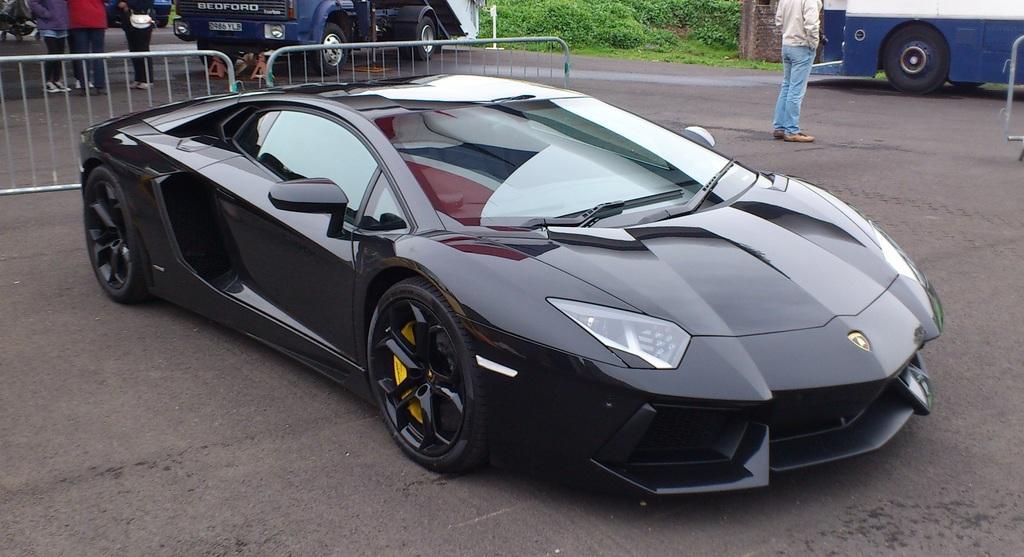Could you give a brief overview of what you see in this image? In this picture I can see vehicles on the road, there are barriers, group of people standing, there are plants. 